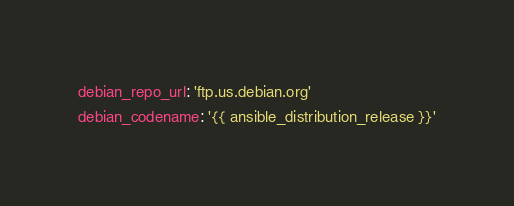<code> <loc_0><loc_0><loc_500><loc_500><_YAML_>debian_repo_url: 'ftp.us.debian.org'
debian_codename: '{{ ansible_distribution_release }}'
</code> 